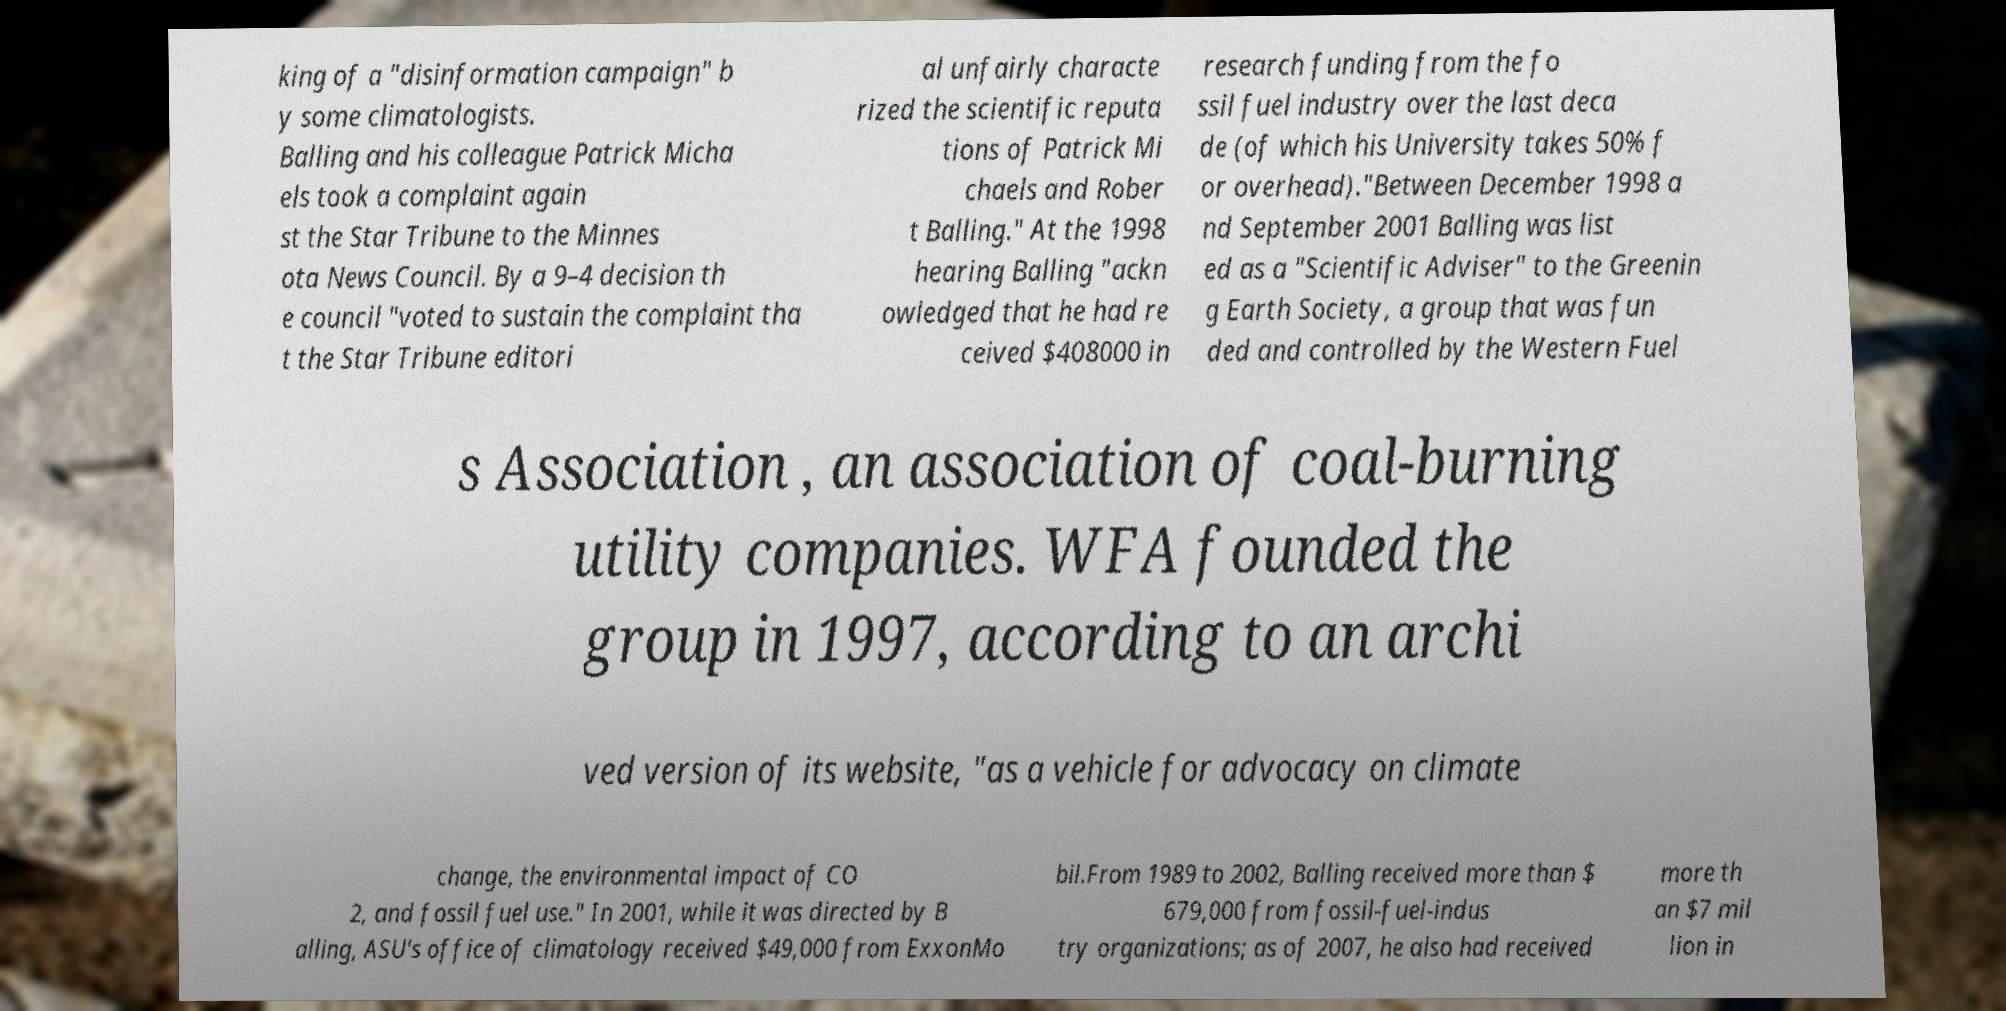Could you assist in decoding the text presented in this image and type it out clearly? king of a "disinformation campaign" b y some climatologists. Balling and his colleague Patrick Micha els took a complaint again st the Star Tribune to the Minnes ota News Council. By a 9–4 decision th e council "voted to sustain the complaint tha t the Star Tribune editori al unfairly characte rized the scientific reputa tions of Patrick Mi chaels and Rober t Balling." At the 1998 hearing Balling "ackn owledged that he had re ceived $408000 in research funding from the fo ssil fuel industry over the last deca de (of which his University takes 50% f or overhead)."Between December 1998 a nd September 2001 Balling was list ed as a "Scientific Adviser" to the Greenin g Earth Society, a group that was fun ded and controlled by the Western Fuel s Association , an association of coal-burning utility companies. WFA founded the group in 1997, according to an archi ved version of its website, "as a vehicle for advocacy on climate change, the environmental impact of CO 2, and fossil fuel use." In 2001, while it was directed by B alling, ASU's office of climatology received $49,000 from ExxonMo bil.From 1989 to 2002, Balling received more than $ 679,000 from fossil-fuel-indus try organizations; as of 2007, he also had received more th an $7 mil lion in 